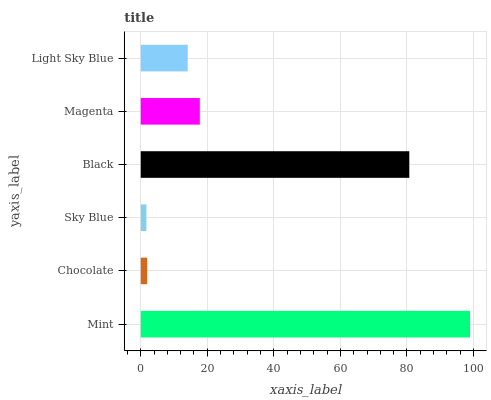Is Sky Blue the minimum?
Answer yes or no. Yes. Is Mint the maximum?
Answer yes or no. Yes. Is Chocolate the minimum?
Answer yes or no. No. Is Chocolate the maximum?
Answer yes or no. No. Is Mint greater than Chocolate?
Answer yes or no. Yes. Is Chocolate less than Mint?
Answer yes or no. Yes. Is Chocolate greater than Mint?
Answer yes or no. No. Is Mint less than Chocolate?
Answer yes or no. No. Is Magenta the high median?
Answer yes or no. Yes. Is Light Sky Blue the low median?
Answer yes or no. Yes. Is Light Sky Blue the high median?
Answer yes or no. No. Is Magenta the low median?
Answer yes or no. No. 